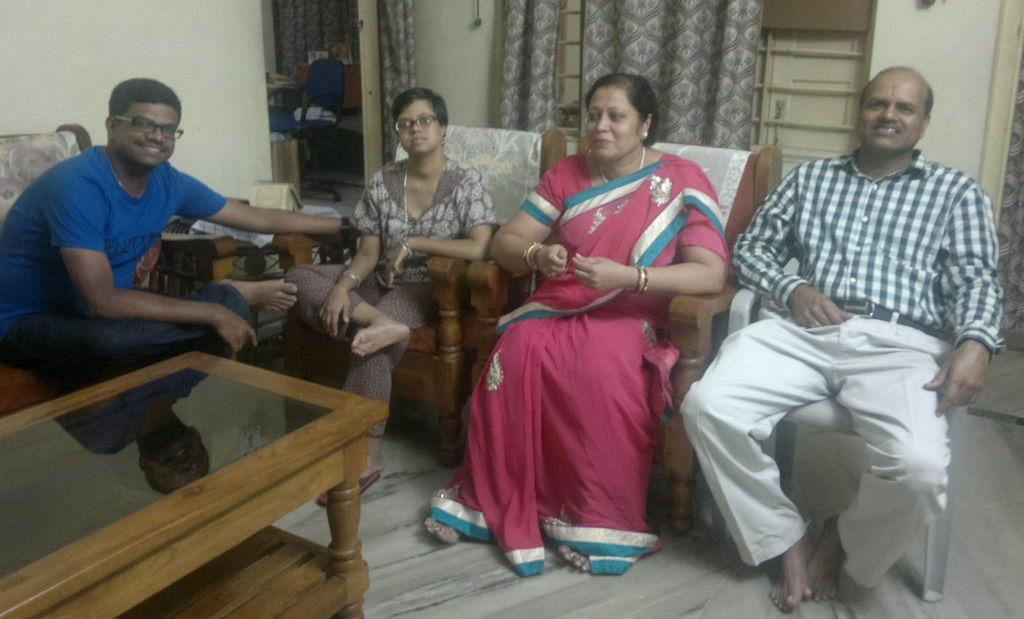How many people are in the image? There are four persons in the image. What are the persons doing in the image? The persons are sitting in chairs. Is there any furniture in front of the persons? Yes, there is a table in front of the persons. What type of sweater is the person on the left wearing in the image? There is no sweater mentioned or visible in the image. What kind of art can be seen hanging on the wall behind the persons? There is no art visible in the image; it only shows the four persons sitting in chairs with a table in front of them. 